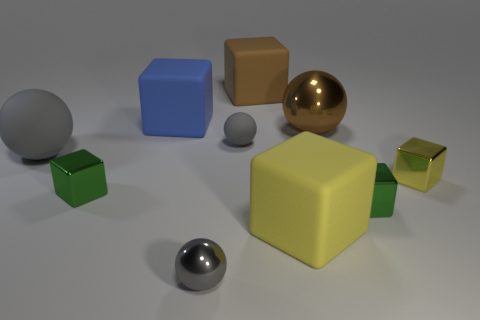Subtract all brown balls. How many balls are left? 3 Subtract all blue cubes. How many cubes are left? 5 Subtract 1 spheres. How many spheres are left? 3 Add 1 green shiny objects. How many green shiny objects are left? 3 Add 3 large blue things. How many large blue things exist? 4 Subtract 0 red cubes. How many objects are left? 10 Subtract all blocks. How many objects are left? 4 Subtract all blue spheres. Subtract all yellow cylinders. How many spheres are left? 4 Subtract all gray spheres. How many yellow cubes are left? 2 Subtract all green objects. Subtract all big gray matte balls. How many objects are left? 7 